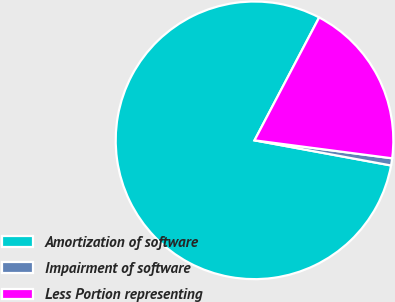Convert chart. <chart><loc_0><loc_0><loc_500><loc_500><pie_chart><fcel>Amortization of software<fcel>Impairment of software<fcel>Less Portion representing<nl><fcel>79.8%<fcel>0.83%<fcel>19.36%<nl></chart> 